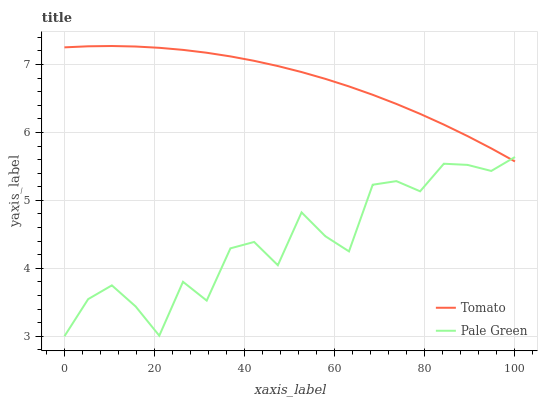Does Pale Green have the minimum area under the curve?
Answer yes or no. Yes. Does Tomato have the maximum area under the curve?
Answer yes or no. Yes. Does Pale Green have the maximum area under the curve?
Answer yes or no. No. Is Tomato the smoothest?
Answer yes or no. Yes. Is Pale Green the roughest?
Answer yes or no. Yes. Is Pale Green the smoothest?
Answer yes or no. No. Does Pale Green have the lowest value?
Answer yes or no. Yes. Does Tomato have the highest value?
Answer yes or no. Yes. Does Pale Green have the highest value?
Answer yes or no. No. Does Tomato intersect Pale Green?
Answer yes or no. Yes. Is Tomato less than Pale Green?
Answer yes or no. No. Is Tomato greater than Pale Green?
Answer yes or no. No. 